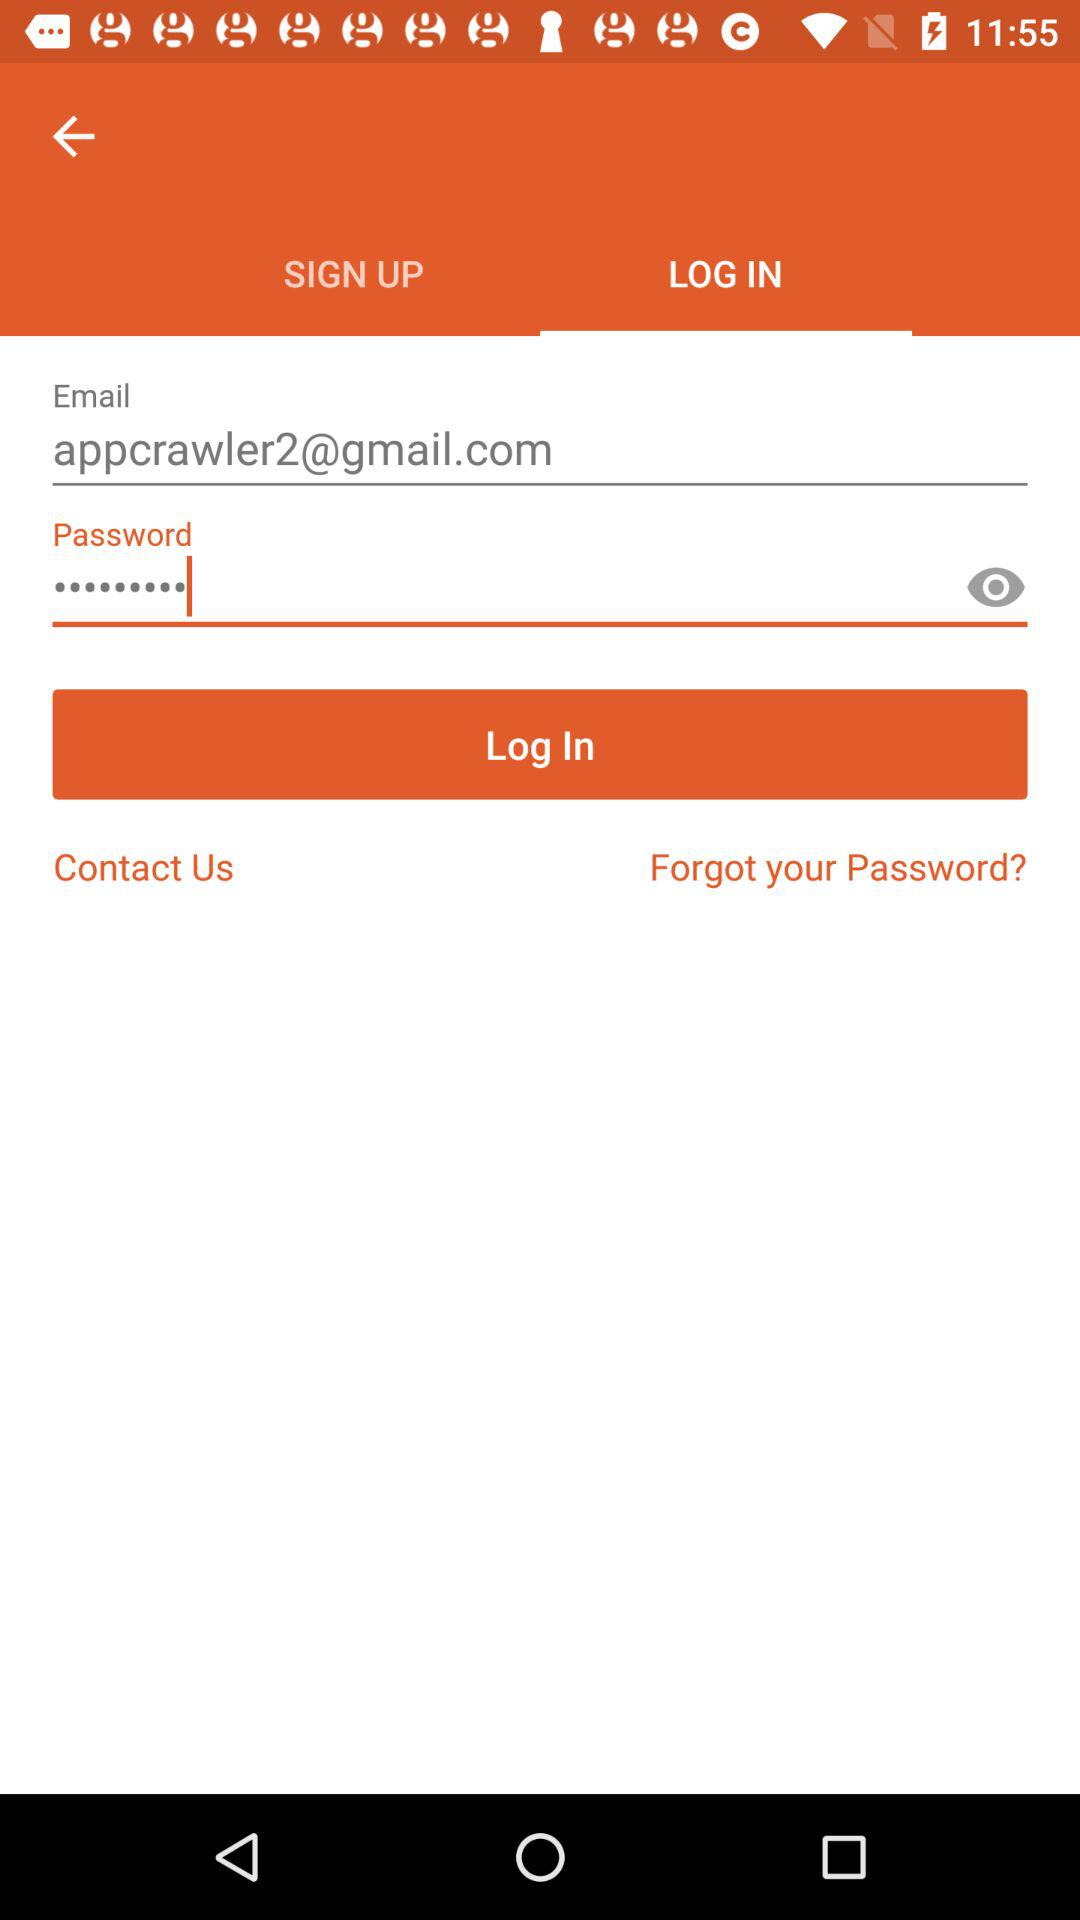Can we reset password?
When the provided information is insufficient, respond with <no answer>. <no answer> 